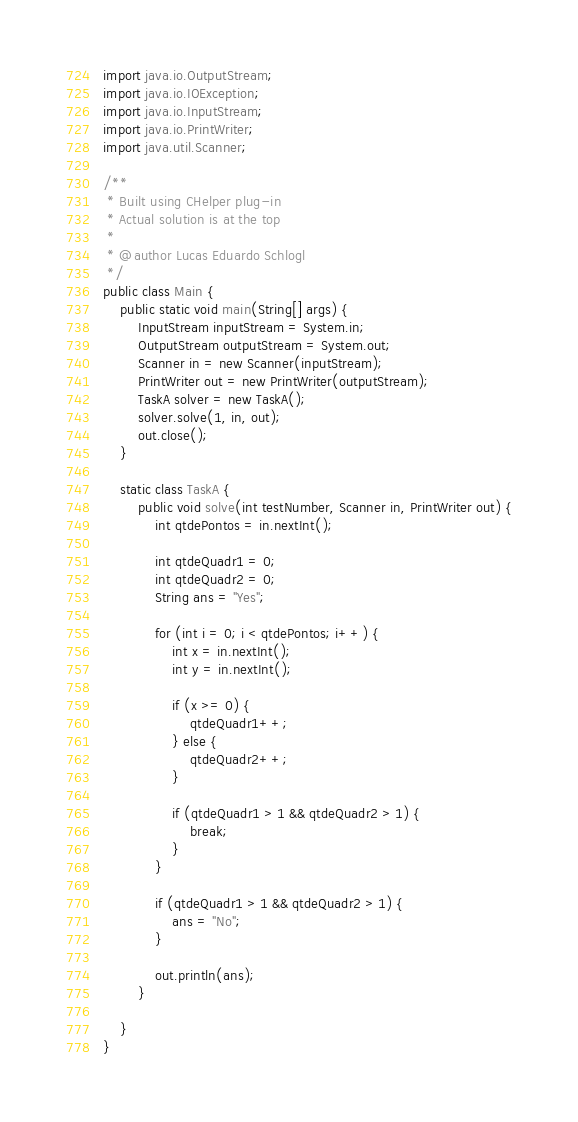Convert code to text. <code><loc_0><loc_0><loc_500><loc_500><_Java_>import java.io.OutputStream;
import java.io.IOException;
import java.io.InputStream;
import java.io.PrintWriter;
import java.util.Scanner;

/**
 * Built using CHelper plug-in
 * Actual solution is at the top
 *
 * @author Lucas Eduardo Schlogl
 */
public class Main {
    public static void main(String[] args) {
        InputStream inputStream = System.in;
        OutputStream outputStream = System.out;
        Scanner in = new Scanner(inputStream);
        PrintWriter out = new PrintWriter(outputStream);
        TaskA solver = new TaskA();
        solver.solve(1, in, out);
        out.close();
    }

    static class TaskA {
        public void solve(int testNumber, Scanner in, PrintWriter out) {
            int qtdePontos = in.nextInt();

            int qtdeQuadr1 = 0;
            int qtdeQuadr2 = 0;
            String ans = "Yes";

            for (int i = 0; i < qtdePontos; i++) {
                int x = in.nextInt();
                int y = in.nextInt();

                if (x >= 0) {
                    qtdeQuadr1++;
                } else {
                    qtdeQuadr2++;
                }

                if (qtdeQuadr1 > 1 && qtdeQuadr2 > 1) {
                    break;
                }
            }

            if (qtdeQuadr1 > 1 && qtdeQuadr2 > 1) {
                ans = "No";
            }

            out.println(ans);
        }

    }
}
</code> 